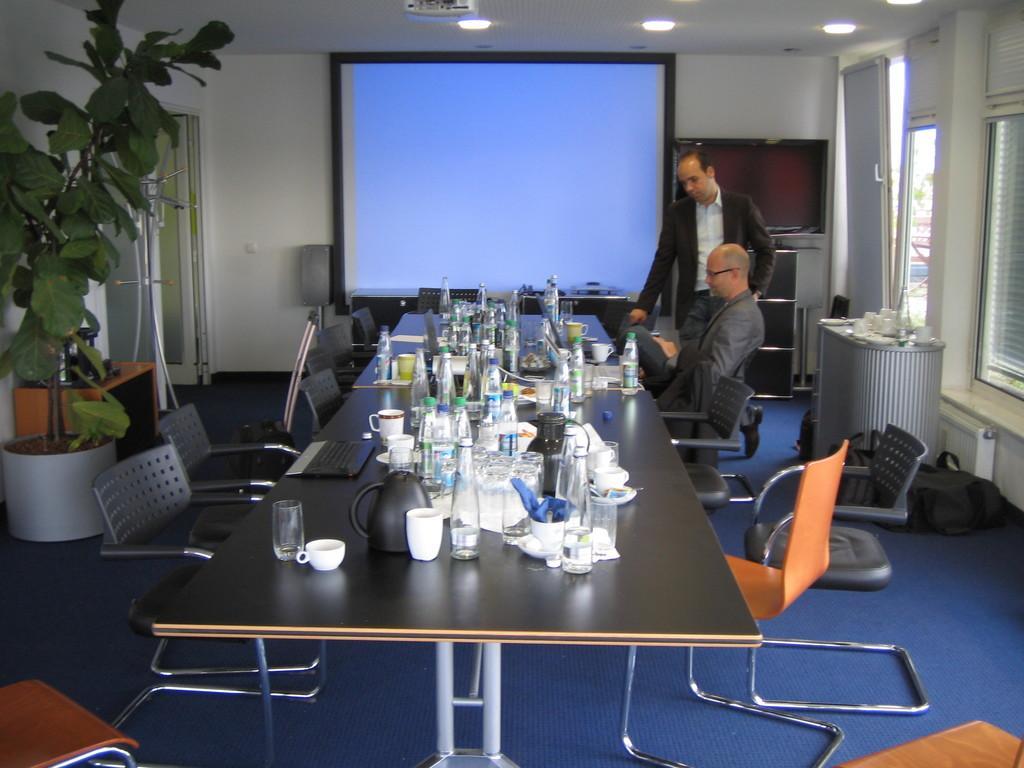Can you describe this image briefly? This picture is clicked inside the room. In the center we can see the chairs and a table on the top of which glasses, bottles, cups and some other items are placed and we can see a house plant and some other items are placed on the ground. On the right corner we can see the windows and window blinds and we can see a person sitting on the chair and a person standing on the floor. In the background we can see the wall, door, projector screen and some other objects. At the top there is a roof, ceiling lights and a projector. 